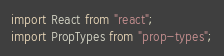<code> <loc_0><loc_0><loc_500><loc_500><_JavaScript_>import React from "react";
import PropTypes from "prop-types";</code> 